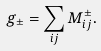<formula> <loc_0><loc_0><loc_500><loc_500>g _ { \pm } = \sum _ { i j } M _ { i j } ^ { \pm } .</formula> 